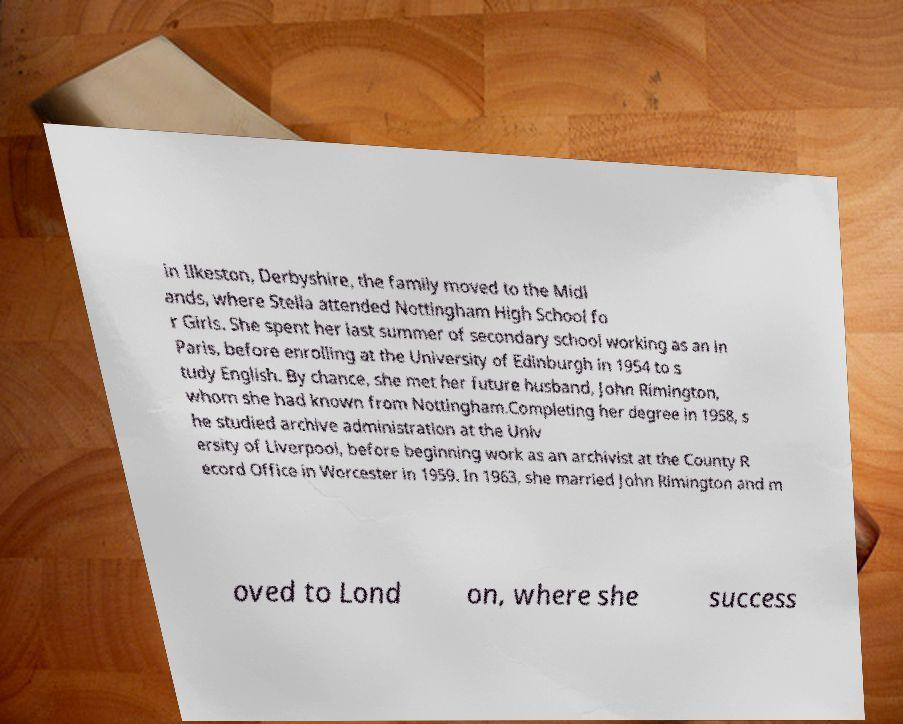Could you assist in decoding the text presented in this image and type it out clearly? in Ilkeston, Derbyshire, the family moved to the Midl ands, where Stella attended Nottingham High School fo r Girls. She spent her last summer of secondary school working as an in Paris, before enrolling at the University of Edinburgh in 1954 to s tudy English. By chance, she met her future husband, John Rimington, whom she had known from Nottingham.Completing her degree in 1958, s he studied archive administration at the Univ ersity of Liverpool, before beginning work as an archivist at the County R ecord Office in Worcester in 1959. In 1963, she married John Rimington and m oved to Lond on, where she success 